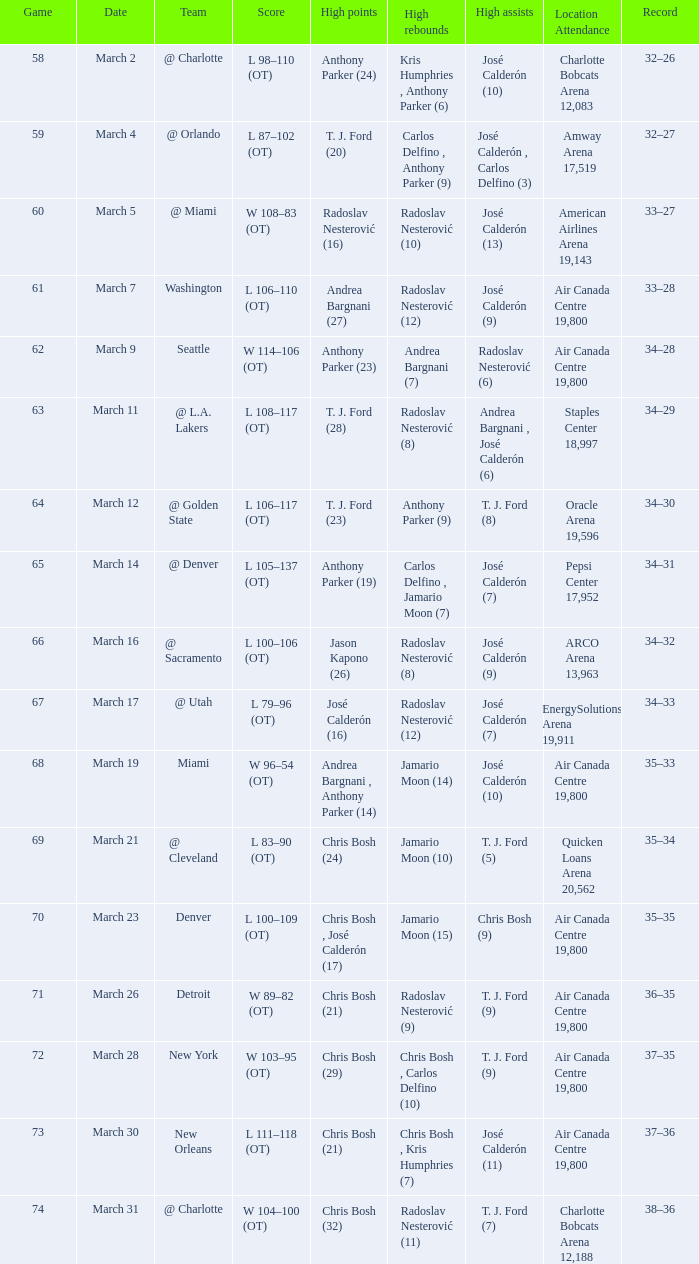Would you mind parsing the complete table? {'header': ['Game', 'Date', 'Team', 'Score', 'High points', 'High rebounds', 'High assists', 'Location Attendance', 'Record'], 'rows': [['58', 'March 2', '@ Charlotte', 'L 98–110 (OT)', 'Anthony Parker (24)', 'Kris Humphries , Anthony Parker (6)', 'José Calderón (10)', 'Charlotte Bobcats Arena 12,083', '32–26'], ['59', 'March 4', '@ Orlando', 'L 87–102 (OT)', 'T. J. Ford (20)', 'Carlos Delfino , Anthony Parker (9)', 'José Calderón , Carlos Delfino (3)', 'Amway Arena 17,519', '32–27'], ['60', 'March 5', '@ Miami', 'W 108–83 (OT)', 'Radoslav Nesterović (16)', 'Radoslav Nesterović (10)', 'José Calderón (13)', 'American Airlines Arena 19,143', '33–27'], ['61', 'March 7', 'Washington', 'L 106–110 (OT)', 'Andrea Bargnani (27)', 'Radoslav Nesterović (12)', 'José Calderón (9)', 'Air Canada Centre 19,800', '33–28'], ['62', 'March 9', 'Seattle', 'W 114–106 (OT)', 'Anthony Parker (23)', 'Andrea Bargnani (7)', 'Radoslav Nesterović (6)', 'Air Canada Centre 19,800', '34–28'], ['63', 'March 11', '@ L.A. Lakers', 'L 108–117 (OT)', 'T. J. Ford (28)', 'Radoslav Nesterović (8)', 'Andrea Bargnani , José Calderón (6)', 'Staples Center 18,997', '34–29'], ['64', 'March 12', '@ Golden State', 'L 106–117 (OT)', 'T. J. Ford (23)', 'Anthony Parker (9)', 'T. J. Ford (8)', 'Oracle Arena 19,596', '34–30'], ['65', 'March 14', '@ Denver', 'L 105–137 (OT)', 'Anthony Parker (19)', 'Carlos Delfino , Jamario Moon (7)', 'José Calderón (7)', 'Pepsi Center 17,952', '34–31'], ['66', 'March 16', '@ Sacramento', 'L 100–106 (OT)', 'Jason Kapono (26)', 'Radoslav Nesterović (8)', 'José Calderón (9)', 'ARCO Arena 13,963', '34–32'], ['67', 'March 17', '@ Utah', 'L 79–96 (OT)', 'José Calderón (16)', 'Radoslav Nesterović (12)', 'José Calderón (7)', 'EnergySolutions Arena 19,911', '34–33'], ['68', 'March 19', 'Miami', 'W 96–54 (OT)', 'Andrea Bargnani , Anthony Parker (14)', 'Jamario Moon (14)', 'José Calderón (10)', 'Air Canada Centre 19,800', '35–33'], ['69', 'March 21', '@ Cleveland', 'L 83–90 (OT)', 'Chris Bosh (24)', 'Jamario Moon (10)', 'T. J. Ford (5)', 'Quicken Loans Arena 20,562', '35–34'], ['70', 'March 23', 'Denver', 'L 100–109 (OT)', 'Chris Bosh , José Calderón (17)', 'Jamario Moon (15)', 'Chris Bosh (9)', 'Air Canada Centre 19,800', '35–35'], ['71', 'March 26', 'Detroit', 'W 89–82 (OT)', 'Chris Bosh (21)', 'Radoslav Nesterović (9)', 'T. J. Ford (9)', 'Air Canada Centre 19,800', '36–35'], ['72', 'March 28', 'New York', 'W 103–95 (OT)', 'Chris Bosh (29)', 'Chris Bosh , Carlos Delfino (10)', 'T. J. Ford (9)', 'Air Canada Centre 19,800', '37–35'], ['73', 'March 30', 'New Orleans', 'L 111–118 (OT)', 'Chris Bosh (21)', 'Chris Bosh , Kris Humphries (7)', 'José Calderón (11)', 'Air Canada Centre 19,800', '37–36'], ['74', 'March 31', '@ Charlotte', 'W 104–100 (OT)', 'Chris Bosh (32)', 'Radoslav Nesterović (11)', 'T. J. Ford (7)', 'Charlotte Bobcats Arena 12,188', '38–36']]} What was the number of attendees at the game on march 16th, after more than 64 games had been played? ARCO Arena 13,963. 